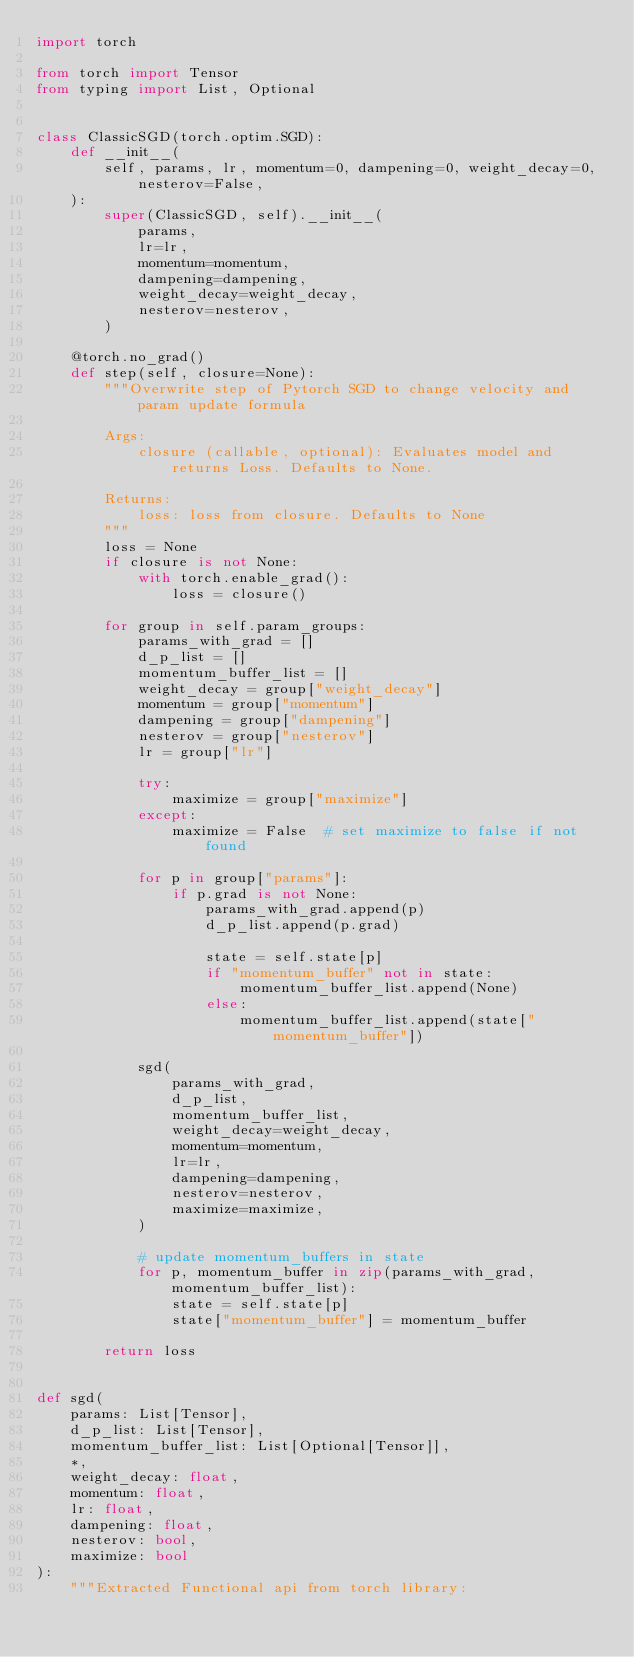Convert code to text. <code><loc_0><loc_0><loc_500><loc_500><_Python_>import torch

from torch import Tensor
from typing import List, Optional


class ClassicSGD(torch.optim.SGD):
    def __init__(
        self, params, lr, momentum=0, dampening=0, weight_decay=0, nesterov=False,
    ):
        super(ClassicSGD, self).__init__(
            params,
            lr=lr,
            momentum=momentum,
            dampening=dampening,
            weight_decay=weight_decay,
            nesterov=nesterov,
        )

    @torch.no_grad()
    def step(self, closure=None):
        """Overwrite step of Pytorch SGD to change velocity and param update formula

        Args:
            closure (callable, optional): Evaluates model and returns Loss. Defaults to None.

        Returns:
            loss: loss from closure. Defaults to None
        """
        loss = None
        if closure is not None:
            with torch.enable_grad():
                loss = closure()

        for group in self.param_groups:
            params_with_grad = []
            d_p_list = []
            momentum_buffer_list = []
            weight_decay = group["weight_decay"]
            momentum = group["momentum"]
            dampening = group["dampening"]
            nesterov = group["nesterov"]
            lr = group["lr"]

            try:
                maximize = group["maximize"]
            except:
                maximize = False  # set maximize to false if not found

            for p in group["params"]:
                if p.grad is not None:
                    params_with_grad.append(p)
                    d_p_list.append(p.grad)

                    state = self.state[p]
                    if "momentum_buffer" not in state:
                        momentum_buffer_list.append(None)
                    else:
                        momentum_buffer_list.append(state["momentum_buffer"])

            sgd(
                params_with_grad,
                d_p_list,
                momentum_buffer_list,
                weight_decay=weight_decay,
                momentum=momentum,
                lr=lr,
                dampening=dampening,
                nesterov=nesterov,
                maximize=maximize,
            )

            # update momentum_buffers in state
            for p, momentum_buffer in zip(params_with_grad, momentum_buffer_list):
                state = self.state[p]
                state["momentum_buffer"] = momentum_buffer

        return loss


def sgd(
    params: List[Tensor],
    d_p_list: List[Tensor],
    momentum_buffer_list: List[Optional[Tensor]],
    *,
    weight_decay: float,
    momentum: float,
    lr: float,
    dampening: float,
    nesterov: bool,
    maximize: bool
):
    """Extracted Functional api from torch library:</code> 